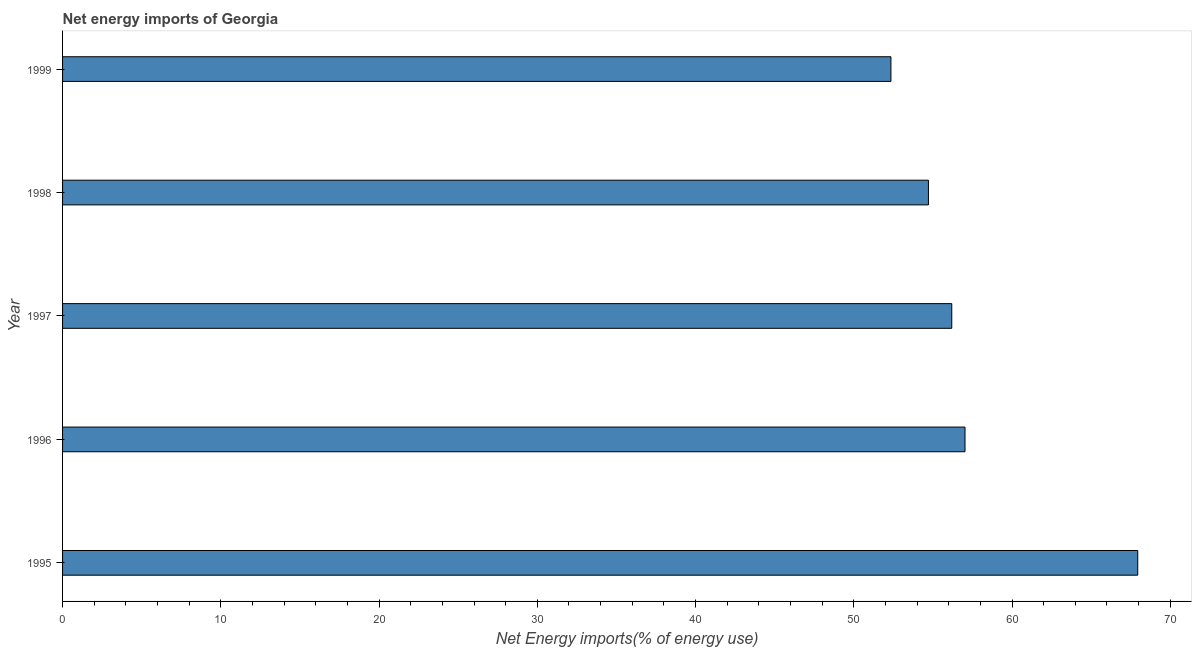Does the graph contain any zero values?
Your answer should be compact. No. What is the title of the graph?
Provide a short and direct response. Net energy imports of Georgia. What is the label or title of the X-axis?
Provide a short and direct response. Net Energy imports(% of energy use). What is the label or title of the Y-axis?
Provide a short and direct response. Year. What is the energy imports in 1996?
Your answer should be very brief. 57.03. Across all years, what is the maximum energy imports?
Your response must be concise. 67.94. Across all years, what is the minimum energy imports?
Make the answer very short. 52.35. What is the sum of the energy imports?
Provide a short and direct response. 288.23. What is the difference between the energy imports in 1995 and 1999?
Your response must be concise. 15.6. What is the average energy imports per year?
Provide a short and direct response. 57.65. What is the median energy imports?
Give a very brief answer. 56.19. In how many years, is the energy imports greater than 8 %?
Your response must be concise. 5. Do a majority of the years between 1999 and 1995 (inclusive) have energy imports greater than 20 %?
Ensure brevity in your answer.  Yes. What is the ratio of the energy imports in 1996 to that in 1999?
Offer a terse response. 1.09. Is the energy imports in 1996 less than that in 1997?
Ensure brevity in your answer.  No. Is the difference between the energy imports in 1995 and 1998 greater than the difference between any two years?
Give a very brief answer. No. What is the difference between the highest and the second highest energy imports?
Keep it short and to the point. 10.91. How many bars are there?
Your answer should be very brief. 5. Are all the bars in the graph horizontal?
Provide a short and direct response. Yes. How many years are there in the graph?
Your answer should be very brief. 5. What is the difference between two consecutive major ticks on the X-axis?
Offer a terse response. 10. Are the values on the major ticks of X-axis written in scientific E-notation?
Your answer should be compact. No. What is the Net Energy imports(% of energy use) in 1995?
Give a very brief answer. 67.94. What is the Net Energy imports(% of energy use) of 1996?
Your answer should be compact. 57.03. What is the Net Energy imports(% of energy use) of 1997?
Ensure brevity in your answer.  56.19. What is the Net Energy imports(% of energy use) in 1998?
Your response must be concise. 54.72. What is the Net Energy imports(% of energy use) of 1999?
Offer a terse response. 52.35. What is the difference between the Net Energy imports(% of energy use) in 1995 and 1996?
Your answer should be compact. 10.91. What is the difference between the Net Energy imports(% of energy use) in 1995 and 1997?
Provide a short and direct response. 11.75. What is the difference between the Net Energy imports(% of energy use) in 1995 and 1998?
Make the answer very short. 13.23. What is the difference between the Net Energy imports(% of energy use) in 1995 and 1999?
Ensure brevity in your answer.  15.6. What is the difference between the Net Energy imports(% of energy use) in 1996 and 1997?
Ensure brevity in your answer.  0.84. What is the difference between the Net Energy imports(% of energy use) in 1996 and 1998?
Offer a very short reply. 2.31. What is the difference between the Net Energy imports(% of energy use) in 1996 and 1999?
Your response must be concise. 4.68. What is the difference between the Net Energy imports(% of energy use) in 1997 and 1998?
Provide a short and direct response. 1.47. What is the difference between the Net Energy imports(% of energy use) in 1997 and 1999?
Offer a terse response. 3.85. What is the difference between the Net Energy imports(% of energy use) in 1998 and 1999?
Your response must be concise. 2.37. What is the ratio of the Net Energy imports(% of energy use) in 1995 to that in 1996?
Ensure brevity in your answer.  1.19. What is the ratio of the Net Energy imports(% of energy use) in 1995 to that in 1997?
Make the answer very short. 1.21. What is the ratio of the Net Energy imports(% of energy use) in 1995 to that in 1998?
Your response must be concise. 1.24. What is the ratio of the Net Energy imports(% of energy use) in 1995 to that in 1999?
Provide a succinct answer. 1.3. What is the ratio of the Net Energy imports(% of energy use) in 1996 to that in 1997?
Keep it short and to the point. 1.01. What is the ratio of the Net Energy imports(% of energy use) in 1996 to that in 1998?
Your response must be concise. 1.04. What is the ratio of the Net Energy imports(% of energy use) in 1996 to that in 1999?
Offer a very short reply. 1.09. What is the ratio of the Net Energy imports(% of energy use) in 1997 to that in 1999?
Offer a very short reply. 1.07. What is the ratio of the Net Energy imports(% of energy use) in 1998 to that in 1999?
Provide a succinct answer. 1.04. 